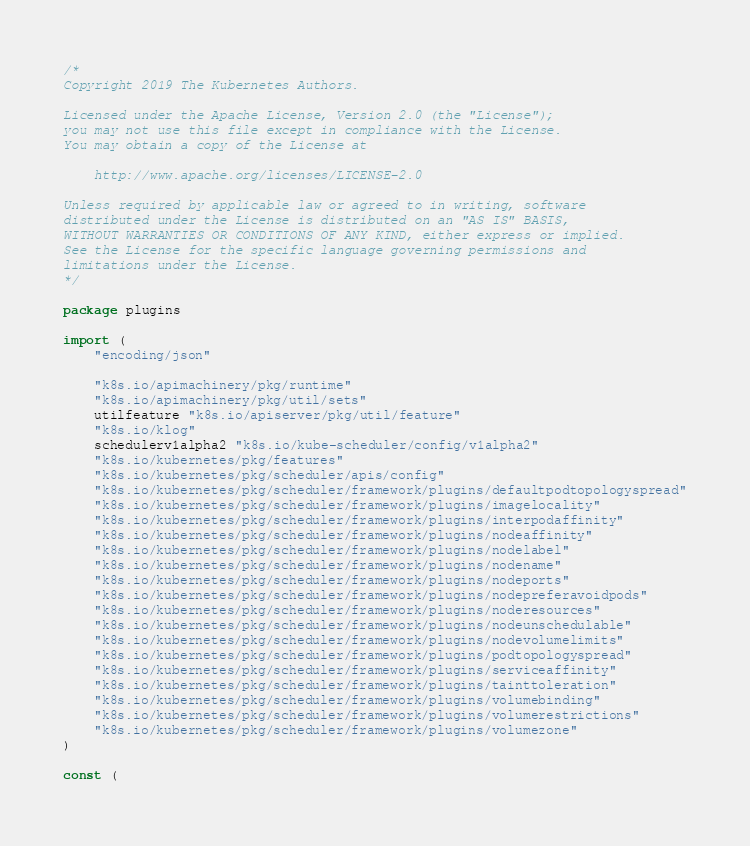<code> <loc_0><loc_0><loc_500><loc_500><_Go_>/*
Copyright 2019 The Kubernetes Authors.

Licensed under the Apache License, Version 2.0 (the "License");
you may not use this file except in compliance with the License.
You may obtain a copy of the License at

    http://www.apache.org/licenses/LICENSE-2.0

Unless required by applicable law or agreed to in writing, software
distributed under the License is distributed on an "AS IS" BASIS,
WITHOUT WARRANTIES OR CONDITIONS OF ANY KIND, either express or implied.
See the License for the specific language governing permissions and
limitations under the License.
*/

package plugins

import (
	"encoding/json"

	"k8s.io/apimachinery/pkg/runtime"
	"k8s.io/apimachinery/pkg/util/sets"
	utilfeature "k8s.io/apiserver/pkg/util/feature"
	"k8s.io/klog"
	schedulerv1alpha2 "k8s.io/kube-scheduler/config/v1alpha2"
	"k8s.io/kubernetes/pkg/features"
	"k8s.io/kubernetes/pkg/scheduler/apis/config"
	"k8s.io/kubernetes/pkg/scheduler/framework/plugins/defaultpodtopologyspread"
	"k8s.io/kubernetes/pkg/scheduler/framework/plugins/imagelocality"
	"k8s.io/kubernetes/pkg/scheduler/framework/plugins/interpodaffinity"
	"k8s.io/kubernetes/pkg/scheduler/framework/plugins/nodeaffinity"
	"k8s.io/kubernetes/pkg/scheduler/framework/plugins/nodelabel"
	"k8s.io/kubernetes/pkg/scheduler/framework/plugins/nodename"
	"k8s.io/kubernetes/pkg/scheduler/framework/plugins/nodeports"
	"k8s.io/kubernetes/pkg/scheduler/framework/plugins/nodepreferavoidpods"
	"k8s.io/kubernetes/pkg/scheduler/framework/plugins/noderesources"
	"k8s.io/kubernetes/pkg/scheduler/framework/plugins/nodeunschedulable"
	"k8s.io/kubernetes/pkg/scheduler/framework/plugins/nodevolumelimits"
	"k8s.io/kubernetes/pkg/scheduler/framework/plugins/podtopologyspread"
	"k8s.io/kubernetes/pkg/scheduler/framework/plugins/serviceaffinity"
	"k8s.io/kubernetes/pkg/scheduler/framework/plugins/tainttoleration"
	"k8s.io/kubernetes/pkg/scheduler/framework/plugins/volumebinding"
	"k8s.io/kubernetes/pkg/scheduler/framework/plugins/volumerestrictions"
	"k8s.io/kubernetes/pkg/scheduler/framework/plugins/volumezone"
)

const (</code> 